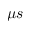<formula> <loc_0><loc_0><loc_500><loc_500>\mu s</formula> 